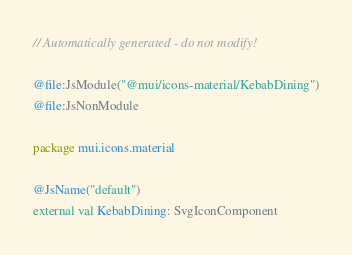Convert code to text. <code><loc_0><loc_0><loc_500><loc_500><_Kotlin_>// Automatically generated - do not modify!

@file:JsModule("@mui/icons-material/KebabDining")
@file:JsNonModule

package mui.icons.material

@JsName("default")
external val KebabDining: SvgIconComponent
</code> 